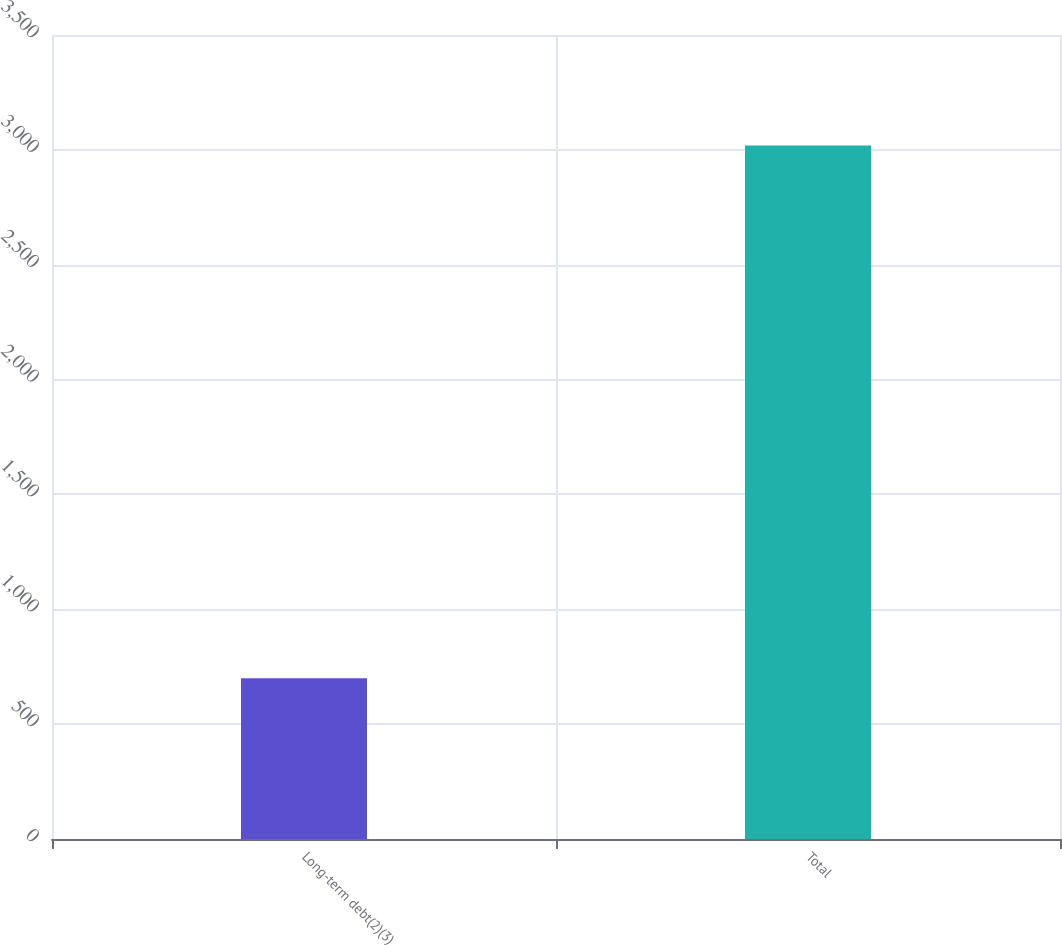Convert chart to OTSL. <chart><loc_0><loc_0><loc_500><loc_500><bar_chart><fcel>Long-term debt(2)(3)<fcel>Total<nl><fcel>700<fcel>3019<nl></chart> 